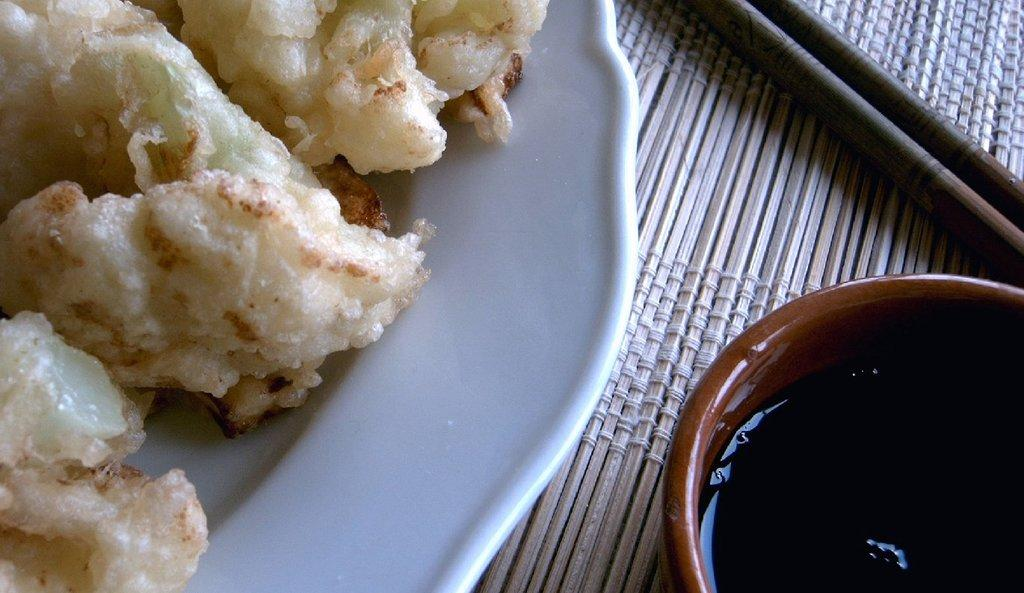What is the primary subject of the image? Food is the main focus of the image. How is the food arranged in the image? The food is presented on a plate. What other item is visible beside the plate? There is a bowl with liquid beside the plate. What utensil is present in the image? Chopsticks are present in the image. What type of hill can be seen in the background of the image? There is no hill visible in the image; it focuses on food presented on a plate with a bowl of liquid and chopsticks. 